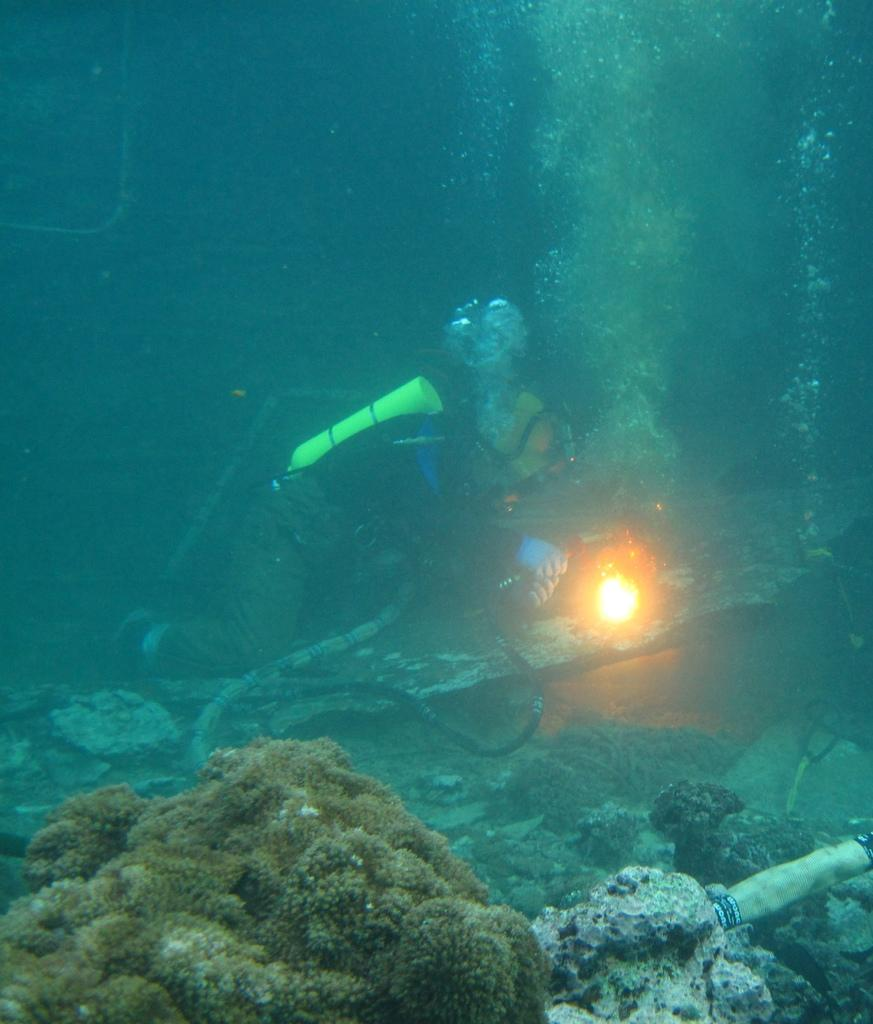Who is in the picture? There is a man in the picture. What is the man wearing? The man is wearing a black jacket. What activity is the man engaged in? The man is scuba diving. What type of environment can be seen in the image? There are rocks and aquatic plants visible in the image. What type of garden can be seen in the image? There is no garden present in the image; it features a man scuba diving in an underwater environment with rocks and aquatic plants. 